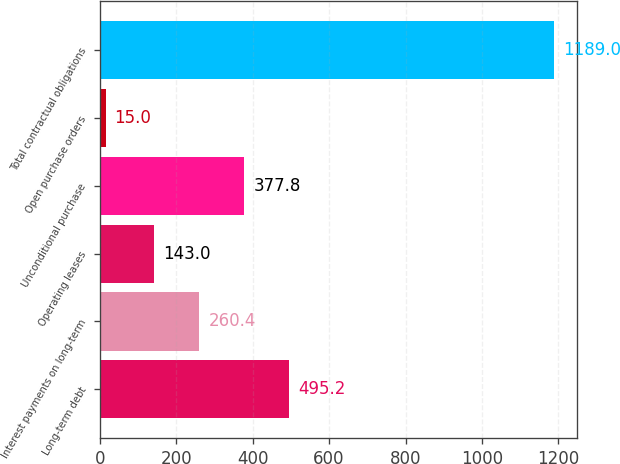<chart> <loc_0><loc_0><loc_500><loc_500><bar_chart><fcel>Long-term debt<fcel>Interest payments on long-term<fcel>Operating leases<fcel>Unconditional purchase<fcel>Open purchase orders<fcel>Total contractual obligations<nl><fcel>495.2<fcel>260.4<fcel>143<fcel>377.8<fcel>15<fcel>1189<nl></chart> 